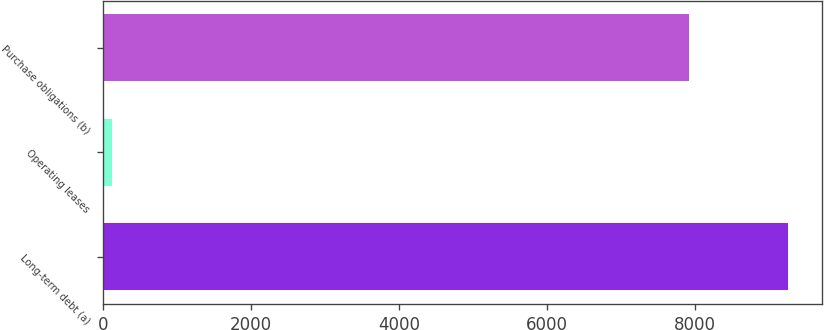Convert chart to OTSL. <chart><loc_0><loc_0><loc_500><loc_500><bar_chart><fcel>Long-term debt (a)<fcel>Operating leases<fcel>Purchase obligations (b)<nl><fcel>9255<fcel>120<fcel>7918<nl></chart> 